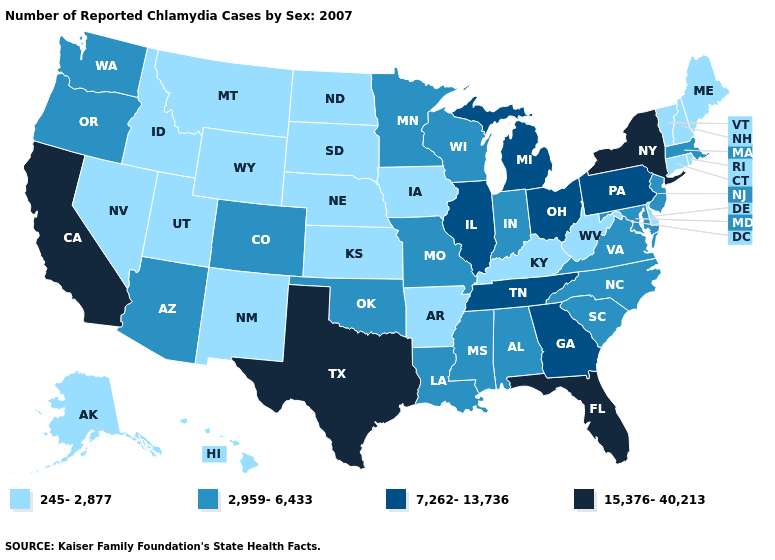Is the legend a continuous bar?
Answer briefly. No. What is the lowest value in the USA?
Quick response, please. 245-2,877. Which states hav the highest value in the Northeast?
Be succinct. New York. What is the highest value in states that border Connecticut?
Write a very short answer. 15,376-40,213. How many symbols are there in the legend?
Short answer required. 4. Does the map have missing data?
Answer briefly. No. Among the states that border South Dakota , which have the lowest value?
Give a very brief answer. Iowa, Montana, Nebraska, North Dakota, Wyoming. What is the value of Colorado?
Keep it brief. 2,959-6,433. Name the states that have a value in the range 245-2,877?
Quick response, please. Alaska, Arkansas, Connecticut, Delaware, Hawaii, Idaho, Iowa, Kansas, Kentucky, Maine, Montana, Nebraska, Nevada, New Hampshire, New Mexico, North Dakota, Rhode Island, South Dakota, Utah, Vermont, West Virginia, Wyoming. What is the lowest value in the USA?
Give a very brief answer. 245-2,877. Which states have the highest value in the USA?
Concise answer only. California, Florida, New York, Texas. What is the value of Ohio?
Keep it brief. 7,262-13,736. What is the highest value in the USA?
Short answer required. 15,376-40,213. Name the states that have a value in the range 15,376-40,213?
Write a very short answer. California, Florida, New York, Texas. 